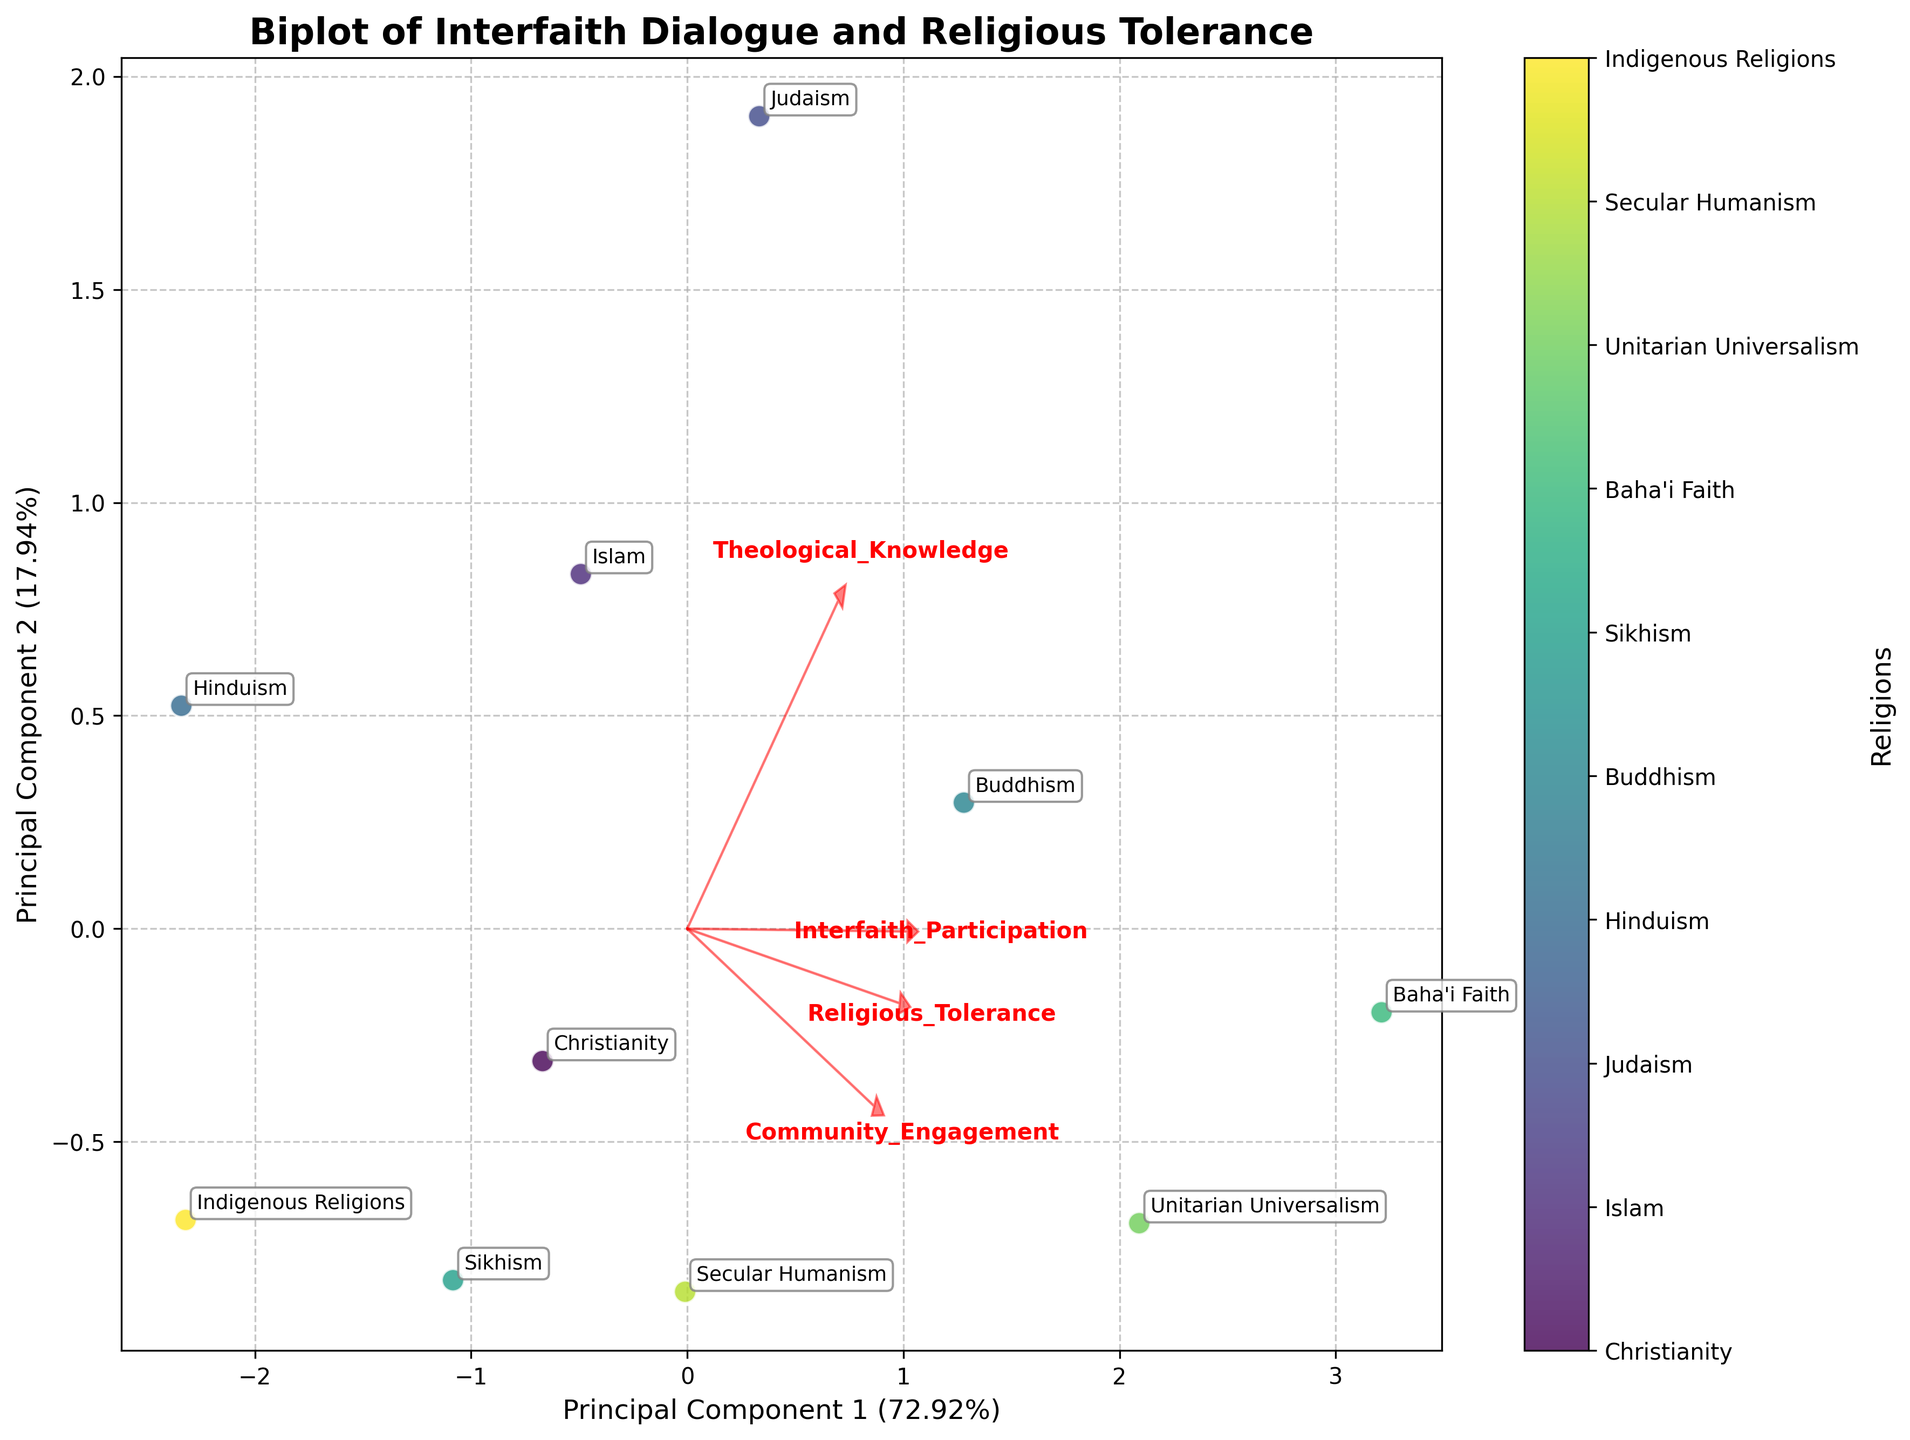What is the title of the figure? The title of the figure is displayed at the top and usually summarizes the content or purpose of the chart.
Answer: Biplot of Interfaith Dialogue and Religious Tolerance How many religions are represented in the figure? Count the number of unique data points labeled with different religions in the plot.
Answer: 10 Which religion has the highest interfaith dialogue participation based on their position in the biplot? In a biplot, higher values of a variable are indicated by a data point's position along the direction of the corresponding loading vector. The religion closest to the vector for "Interfaith_Participation" is Baha'i Faith.
Answer: Baha'i Faith Which two variables are most important in explaining the variance in the dataset based on the length of the vectors? In a biplot, the importance of a variable in explaining variance is indicated by the length of its corresponding loading vector.
Answer: Theological_Knowledge and Interfaith_Participation Which religion shows a relatively high community engagement but moderate theological knowledge? Find the data point that is far along the vector for "Community_Engagement" but not as far along the vector for "Theological_Knowledge". This is Christianity.
Answer: Christianity Which religion appears to have almost equal interfaith participation and religious tolerance? Find the religion that lies near the intersection or equal distance along the vectors for "Interfaith_Participation" and "Religious_Tolerance". Unitarian Universalism satisfies this condition.
Answer: Unitarian Universalism What can be inferred about Indigenous Religions in terms of interfaith participation and community engagement? Indigenous Religions are located at a lower value along the vectors for "Interfaith_Participation" and moderate for "Community_Engagement," indicating low participation and moderate engagement.
Answer: Low participation and moderate engagement 